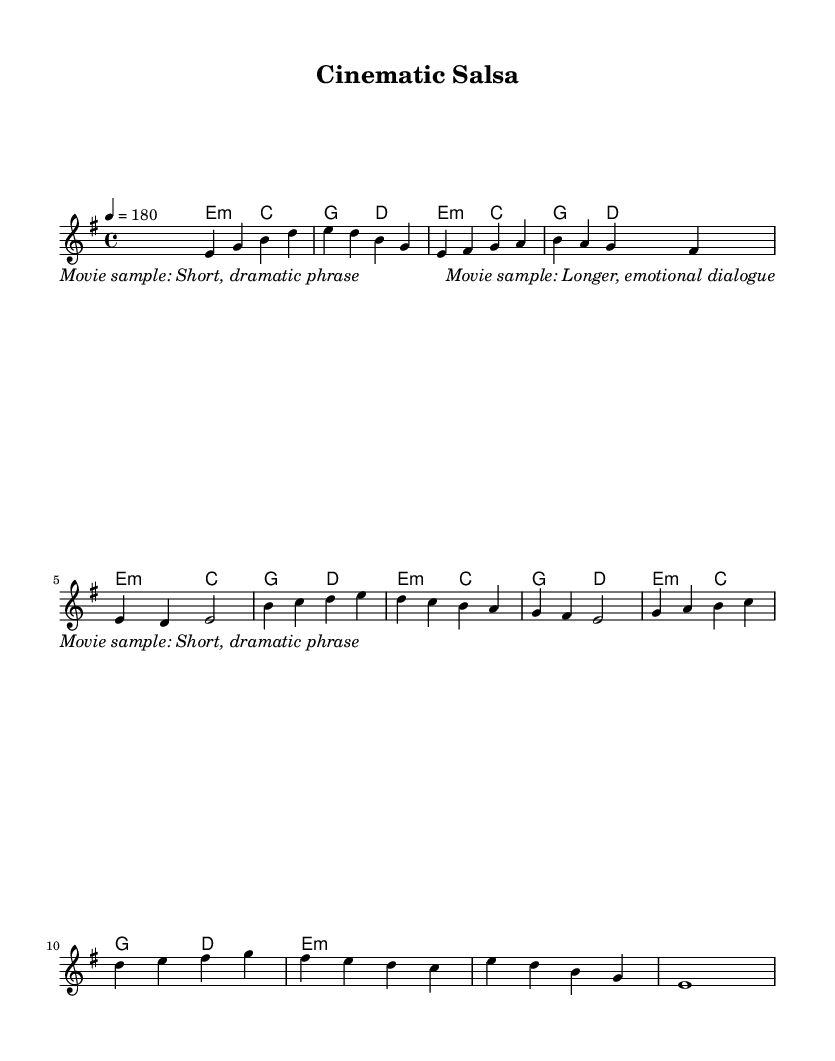What is the key signature of this music? The key signature is E minor, which has one sharp (F#). This is inferred from the key indication at the beginning of the score.
Answer: E minor What is the time signature of this music? The time signature shown is 4/4, indicated at the start of the score. Each measure contains four beats, and the quarter note gets one beat.
Answer: 4/4 What is the tempo marking for this piece? The tempo indication is 4 = 180, meaning there are 180 quarter note beats per minute. This is found directly in the tempo marking at the beginning of the score.
Answer: 180 How many measures are in the melody section? The melody section consists of 13 measures, which can be counted by looking at the division of sections in the written score.
Answer: 13 What is the main genre of this piece based on its attributes? The piece is classified as salsa, a genre associated with Latin music characterized by its rhythmic and lively style. This can be inferred from the title "Cinematic Salsa" and the rhythmic pattern typical for salsa music.
Answer: Salsa Identify the chord used in the first measure. The first measure uses the E minor chord. This is determined by looking at the chord symbol corresponding to the melody notes in the first measure.
Answer: E minor 